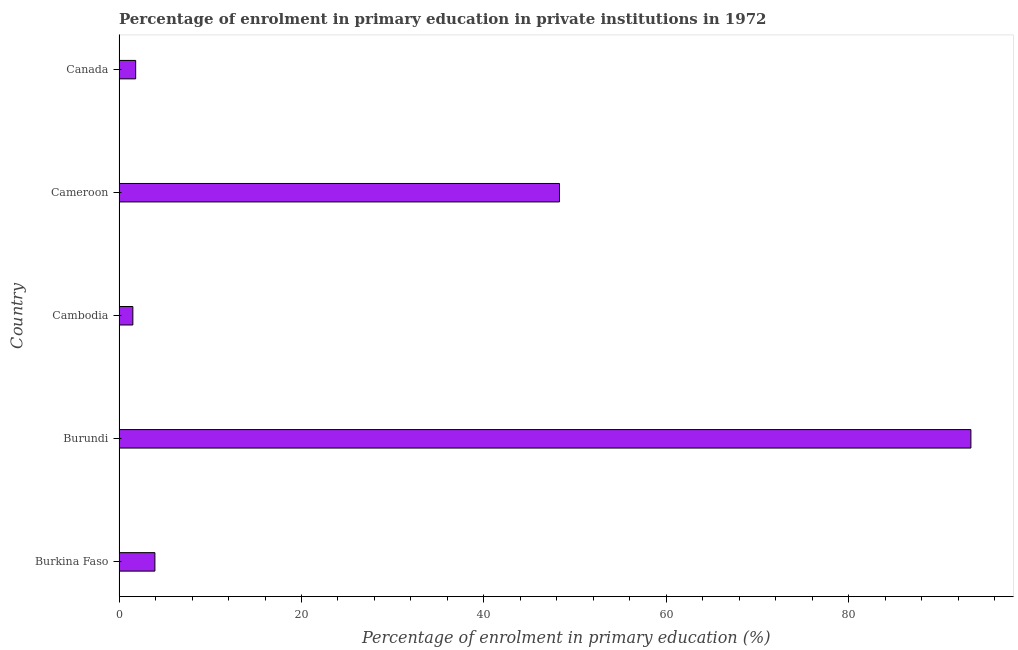What is the title of the graph?
Ensure brevity in your answer.  Percentage of enrolment in primary education in private institutions in 1972. What is the label or title of the X-axis?
Offer a terse response. Percentage of enrolment in primary education (%). What is the enrolment percentage in primary education in Burundi?
Ensure brevity in your answer.  93.38. Across all countries, what is the maximum enrolment percentage in primary education?
Offer a very short reply. 93.38. Across all countries, what is the minimum enrolment percentage in primary education?
Provide a short and direct response. 1.51. In which country was the enrolment percentage in primary education maximum?
Your response must be concise. Burundi. In which country was the enrolment percentage in primary education minimum?
Provide a short and direct response. Cambodia. What is the sum of the enrolment percentage in primary education?
Your answer should be compact. 148.93. What is the difference between the enrolment percentage in primary education in Cambodia and Cameroon?
Keep it short and to the point. -46.77. What is the average enrolment percentage in primary education per country?
Ensure brevity in your answer.  29.79. What is the median enrolment percentage in primary education?
Provide a short and direct response. 3.93. What is the ratio of the enrolment percentage in primary education in Burkina Faso to that in Cameroon?
Offer a very short reply. 0.08. Is the difference between the enrolment percentage in primary education in Burundi and Canada greater than the difference between any two countries?
Your answer should be compact. No. What is the difference between the highest and the second highest enrolment percentage in primary education?
Make the answer very short. 45.1. Is the sum of the enrolment percentage in primary education in Burundi and Cameroon greater than the maximum enrolment percentage in primary education across all countries?
Your answer should be very brief. Yes. What is the difference between the highest and the lowest enrolment percentage in primary education?
Keep it short and to the point. 91.87. What is the difference between two consecutive major ticks on the X-axis?
Your response must be concise. 20. What is the Percentage of enrolment in primary education (%) of Burkina Faso?
Your answer should be compact. 3.93. What is the Percentage of enrolment in primary education (%) of Burundi?
Offer a terse response. 93.38. What is the Percentage of enrolment in primary education (%) in Cambodia?
Offer a very short reply. 1.51. What is the Percentage of enrolment in primary education (%) of Cameroon?
Make the answer very short. 48.28. What is the Percentage of enrolment in primary education (%) of Canada?
Offer a very short reply. 1.82. What is the difference between the Percentage of enrolment in primary education (%) in Burkina Faso and Burundi?
Provide a short and direct response. -89.45. What is the difference between the Percentage of enrolment in primary education (%) in Burkina Faso and Cambodia?
Make the answer very short. 2.42. What is the difference between the Percentage of enrolment in primary education (%) in Burkina Faso and Cameroon?
Provide a short and direct response. -44.35. What is the difference between the Percentage of enrolment in primary education (%) in Burkina Faso and Canada?
Ensure brevity in your answer.  2.11. What is the difference between the Percentage of enrolment in primary education (%) in Burundi and Cambodia?
Provide a short and direct response. 91.87. What is the difference between the Percentage of enrolment in primary education (%) in Burundi and Cameroon?
Keep it short and to the point. 45.1. What is the difference between the Percentage of enrolment in primary education (%) in Burundi and Canada?
Ensure brevity in your answer.  91.56. What is the difference between the Percentage of enrolment in primary education (%) in Cambodia and Cameroon?
Your answer should be very brief. -46.77. What is the difference between the Percentage of enrolment in primary education (%) in Cambodia and Canada?
Make the answer very short. -0.31. What is the difference between the Percentage of enrolment in primary education (%) in Cameroon and Canada?
Keep it short and to the point. 46.46. What is the ratio of the Percentage of enrolment in primary education (%) in Burkina Faso to that in Burundi?
Provide a succinct answer. 0.04. What is the ratio of the Percentage of enrolment in primary education (%) in Burkina Faso to that in Cambodia?
Provide a succinct answer. 2.6. What is the ratio of the Percentage of enrolment in primary education (%) in Burkina Faso to that in Cameroon?
Keep it short and to the point. 0.08. What is the ratio of the Percentage of enrolment in primary education (%) in Burkina Faso to that in Canada?
Your answer should be compact. 2.16. What is the ratio of the Percentage of enrolment in primary education (%) in Burundi to that in Cambodia?
Give a very brief answer. 61.71. What is the ratio of the Percentage of enrolment in primary education (%) in Burundi to that in Cameroon?
Provide a short and direct response. 1.93. What is the ratio of the Percentage of enrolment in primary education (%) in Burundi to that in Canada?
Your answer should be compact. 51.26. What is the ratio of the Percentage of enrolment in primary education (%) in Cambodia to that in Cameroon?
Make the answer very short. 0.03. What is the ratio of the Percentage of enrolment in primary education (%) in Cambodia to that in Canada?
Your response must be concise. 0.83. What is the ratio of the Percentage of enrolment in primary education (%) in Cameroon to that in Canada?
Your answer should be very brief. 26.5. 